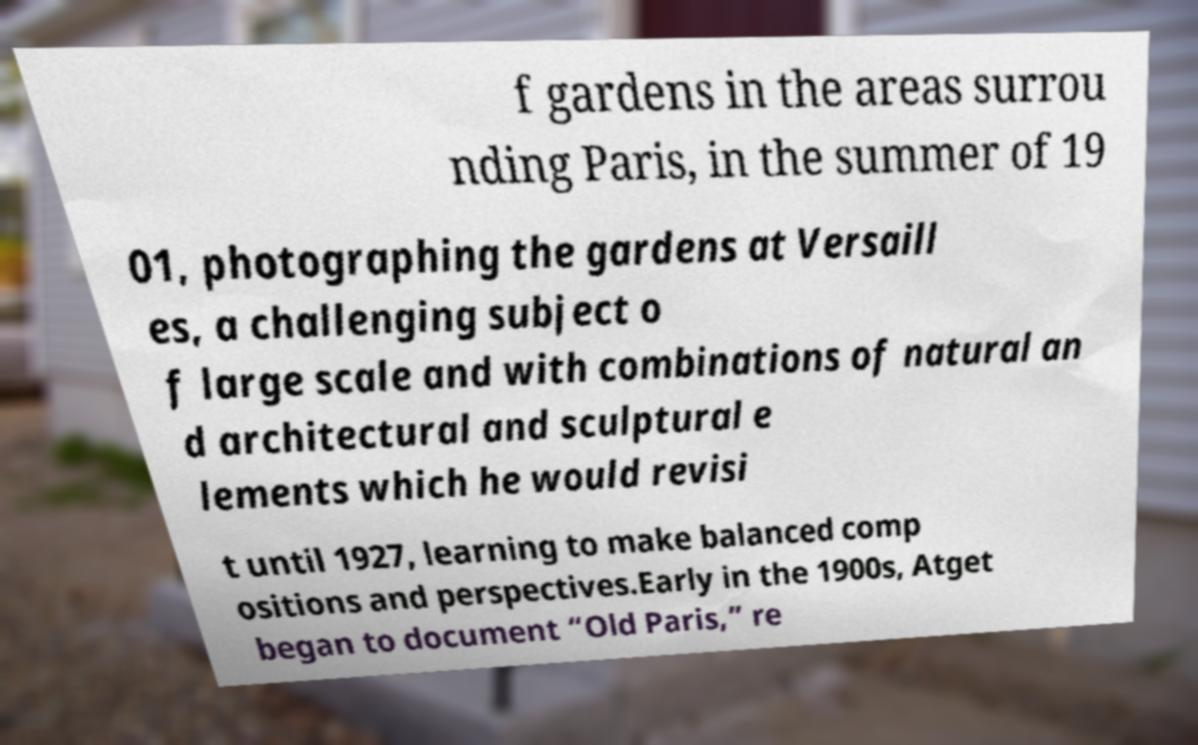I need the written content from this picture converted into text. Can you do that? f gardens in the areas surrou nding Paris, in the summer of 19 01, photographing the gardens at Versaill es, a challenging subject o f large scale and with combinations of natural an d architectural and sculptural e lements which he would revisi t until 1927, learning to make balanced comp ositions and perspectives.Early in the 1900s, Atget began to document “Old Paris,” re 